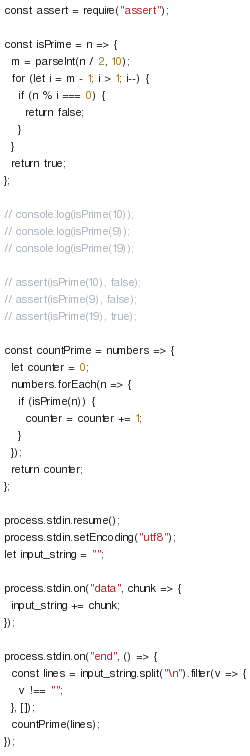<code> <loc_0><loc_0><loc_500><loc_500><_JavaScript_>const assert = require("assert");

const isPrime = n => {
  m = parseInt(n / 2, 10);
  for (let i = m - 1; i > 1; i--) {
    if (n % i === 0) {
      return false;
    }
  }
  return true;
};

// console.log(isPrime(10));
// console.log(isPrime(9));
// console.log(isPrime(19));

// assert(isPrime(10), false);
// assert(isPrime(9), false);
// assert(isPrime(19), true);

const countPrime = numbers => {
  let counter = 0;
  numbers.forEach(n => {
    if (isPrime(n)) {
      counter = counter += 1;
    }
  });
  return counter;
};

process.stdin.resume();
process.stdin.setEncoding("utf8");
let input_string = "";

process.stdin.on("data", chunk => {
  input_string += chunk;
});

process.stdin.on("end", () => {
  const lines = input_string.split("\n").filter(v => {
    v !== "";
  }, []);
  countPrime(lines);
});

</code> 